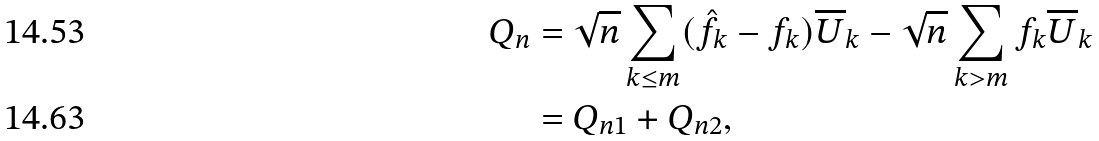<formula> <loc_0><loc_0><loc_500><loc_500>Q _ { n } & = \sqrt { n } \sum _ { k \leq m } ( \hat { f _ { k } } - f _ { k } ) \overline { U } _ { k } - \sqrt { n } \sum _ { k > m } f _ { k } \overline { U } _ { k } \\ & = Q _ { n 1 } + Q _ { n 2 } ,</formula> 